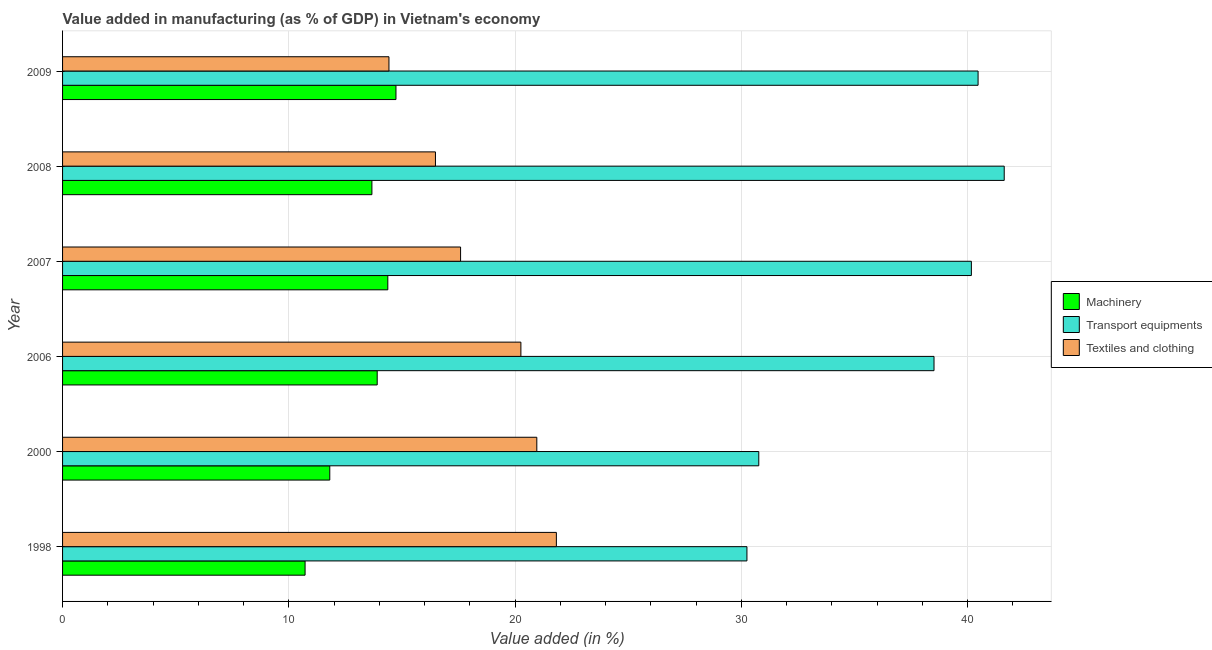How many bars are there on the 1st tick from the top?
Your answer should be very brief. 3. What is the label of the 5th group of bars from the top?
Give a very brief answer. 2000. In how many cases, is the number of bars for a given year not equal to the number of legend labels?
Make the answer very short. 0. What is the value added in manufacturing textile and clothing in 2007?
Your response must be concise. 17.59. Across all years, what is the maximum value added in manufacturing machinery?
Provide a succinct answer. 14.74. Across all years, what is the minimum value added in manufacturing transport equipments?
Keep it short and to the point. 30.25. In which year was the value added in manufacturing machinery minimum?
Make the answer very short. 1998. What is the total value added in manufacturing textile and clothing in the graph?
Your answer should be very brief. 111.55. What is the difference between the value added in manufacturing machinery in 2006 and that in 2009?
Give a very brief answer. -0.83. What is the difference between the value added in manufacturing transport equipments in 2007 and the value added in manufacturing textile and clothing in 1998?
Your response must be concise. 18.34. What is the average value added in manufacturing textile and clothing per year?
Offer a terse response. 18.59. In the year 2009, what is the difference between the value added in manufacturing textile and clothing and value added in manufacturing machinery?
Provide a short and direct response. -0.31. What is the ratio of the value added in manufacturing textile and clothing in 2007 to that in 2008?
Provide a short and direct response. 1.07. What is the difference between the highest and the second highest value added in manufacturing transport equipments?
Your answer should be very brief. 1.16. What is the difference between the highest and the lowest value added in manufacturing machinery?
Offer a terse response. 4.02. Is the sum of the value added in manufacturing transport equipments in 2006 and 2008 greater than the maximum value added in manufacturing machinery across all years?
Provide a succinct answer. Yes. What does the 1st bar from the top in 2009 represents?
Your answer should be very brief. Textiles and clothing. What does the 2nd bar from the bottom in 2008 represents?
Offer a very short reply. Transport equipments. Is it the case that in every year, the sum of the value added in manufacturing machinery and value added in manufacturing transport equipments is greater than the value added in manufacturing textile and clothing?
Provide a short and direct response. Yes. How many bars are there?
Give a very brief answer. 18. How many years are there in the graph?
Ensure brevity in your answer.  6. What is the difference between two consecutive major ticks on the X-axis?
Provide a succinct answer. 10. Are the values on the major ticks of X-axis written in scientific E-notation?
Give a very brief answer. No. Does the graph contain any zero values?
Keep it short and to the point. No. Does the graph contain grids?
Offer a terse response. Yes. How many legend labels are there?
Your response must be concise. 3. How are the legend labels stacked?
Keep it short and to the point. Vertical. What is the title of the graph?
Offer a very short reply. Value added in manufacturing (as % of GDP) in Vietnam's economy. What is the label or title of the X-axis?
Keep it short and to the point. Value added (in %). What is the Value added (in %) in Machinery in 1998?
Your response must be concise. 10.72. What is the Value added (in %) in Transport equipments in 1998?
Keep it short and to the point. 30.25. What is the Value added (in %) in Textiles and clothing in 1998?
Ensure brevity in your answer.  21.83. What is the Value added (in %) of Machinery in 2000?
Provide a succinct answer. 11.81. What is the Value added (in %) of Transport equipments in 2000?
Provide a succinct answer. 30.77. What is the Value added (in %) of Textiles and clothing in 2000?
Make the answer very short. 20.96. What is the Value added (in %) in Machinery in 2006?
Offer a terse response. 13.91. What is the Value added (in %) of Transport equipments in 2006?
Your response must be concise. 38.52. What is the Value added (in %) of Textiles and clothing in 2006?
Your response must be concise. 20.26. What is the Value added (in %) of Machinery in 2007?
Your response must be concise. 14.38. What is the Value added (in %) of Transport equipments in 2007?
Offer a very short reply. 40.17. What is the Value added (in %) of Textiles and clothing in 2007?
Offer a very short reply. 17.59. What is the Value added (in %) in Machinery in 2008?
Your answer should be compact. 13.67. What is the Value added (in %) in Transport equipments in 2008?
Offer a very short reply. 41.62. What is the Value added (in %) in Textiles and clothing in 2008?
Offer a terse response. 16.48. What is the Value added (in %) of Machinery in 2009?
Offer a very short reply. 14.74. What is the Value added (in %) of Transport equipments in 2009?
Keep it short and to the point. 40.47. What is the Value added (in %) in Textiles and clothing in 2009?
Offer a terse response. 14.43. Across all years, what is the maximum Value added (in %) of Machinery?
Your answer should be compact. 14.74. Across all years, what is the maximum Value added (in %) of Transport equipments?
Offer a terse response. 41.62. Across all years, what is the maximum Value added (in %) of Textiles and clothing?
Offer a terse response. 21.83. Across all years, what is the minimum Value added (in %) in Machinery?
Offer a very short reply. 10.72. Across all years, what is the minimum Value added (in %) of Transport equipments?
Give a very brief answer. 30.25. Across all years, what is the minimum Value added (in %) in Textiles and clothing?
Give a very brief answer. 14.43. What is the total Value added (in %) in Machinery in the graph?
Your answer should be very brief. 79.23. What is the total Value added (in %) of Transport equipments in the graph?
Offer a terse response. 221.81. What is the total Value added (in %) in Textiles and clothing in the graph?
Your answer should be compact. 111.55. What is the difference between the Value added (in %) of Machinery in 1998 and that in 2000?
Your response must be concise. -1.09. What is the difference between the Value added (in %) of Transport equipments in 1998 and that in 2000?
Your answer should be compact. -0.52. What is the difference between the Value added (in %) in Textiles and clothing in 1998 and that in 2000?
Your answer should be compact. 0.86. What is the difference between the Value added (in %) in Machinery in 1998 and that in 2006?
Your response must be concise. -3.19. What is the difference between the Value added (in %) of Transport equipments in 1998 and that in 2006?
Keep it short and to the point. -8.27. What is the difference between the Value added (in %) in Textiles and clothing in 1998 and that in 2006?
Your response must be concise. 1.57. What is the difference between the Value added (in %) of Machinery in 1998 and that in 2007?
Provide a succinct answer. -3.66. What is the difference between the Value added (in %) in Transport equipments in 1998 and that in 2007?
Make the answer very short. -9.92. What is the difference between the Value added (in %) of Textiles and clothing in 1998 and that in 2007?
Ensure brevity in your answer.  4.23. What is the difference between the Value added (in %) in Machinery in 1998 and that in 2008?
Provide a short and direct response. -2.95. What is the difference between the Value added (in %) in Transport equipments in 1998 and that in 2008?
Provide a short and direct response. -11.37. What is the difference between the Value added (in %) of Textiles and clothing in 1998 and that in 2008?
Ensure brevity in your answer.  5.34. What is the difference between the Value added (in %) in Machinery in 1998 and that in 2009?
Ensure brevity in your answer.  -4.02. What is the difference between the Value added (in %) of Transport equipments in 1998 and that in 2009?
Make the answer very short. -10.22. What is the difference between the Value added (in %) of Textiles and clothing in 1998 and that in 2009?
Your answer should be compact. 7.4. What is the difference between the Value added (in %) in Machinery in 2000 and that in 2006?
Provide a short and direct response. -2.1. What is the difference between the Value added (in %) in Transport equipments in 2000 and that in 2006?
Your answer should be very brief. -7.75. What is the difference between the Value added (in %) in Textiles and clothing in 2000 and that in 2006?
Make the answer very short. 0.7. What is the difference between the Value added (in %) of Machinery in 2000 and that in 2007?
Your answer should be very brief. -2.56. What is the difference between the Value added (in %) of Transport equipments in 2000 and that in 2007?
Offer a very short reply. -9.4. What is the difference between the Value added (in %) of Textiles and clothing in 2000 and that in 2007?
Offer a very short reply. 3.37. What is the difference between the Value added (in %) of Machinery in 2000 and that in 2008?
Provide a short and direct response. -1.86. What is the difference between the Value added (in %) in Transport equipments in 2000 and that in 2008?
Make the answer very short. -10.85. What is the difference between the Value added (in %) of Textiles and clothing in 2000 and that in 2008?
Your answer should be very brief. 4.48. What is the difference between the Value added (in %) in Machinery in 2000 and that in 2009?
Your answer should be very brief. -2.93. What is the difference between the Value added (in %) in Transport equipments in 2000 and that in 2009?
Give a very brief answer. -9.69. What is the difference between the Value added (in %) in Textiles and clothing in 2000 and that in 2009?
Offer a very short reply. 6.54. What is the difference between the Value added (in %) in Machinery in 2006 and that in 2007?
Provide a succinct answer. -0.47. What is the difference between the Value added (in %) of Transport equipments in 2006 and that in 2007?
Provide a short and direct response. -1.65. What is the difference between the Value added (in %) of Textiles and clothing in 2006 and that in 2007?
Provide a short and direct response. 2.67. What is the difference between the Value added (in %) in Machinery in 2006 and that in 2008?
Offer a very short reply. 0.23. What is the difference between the Value added (in %) in Transport equipments in 2006 and that in 2008?
Provide a succinct answer. -3.1. What is the difference between the Value added (in %) in Textiles and clothing in 2006 and that in 2008?
Keep it short and to the point. 3.78. What is the difference between the Value added (in %) of Machinery in 2006 and that in 2009?
Make the answer very short. -0.83. What is the difference between the Value added (in %) of Transport equipments in 2006 and that in 2009?
Keep it short and to the point. -1.95. What is the difference between the Value added (in %) in Textiles and clothing in 2006 and that in 2009?
Your response must be concise. 5.83. What is the difference between the Value added (in %) of Machinery in 2007 and that in 2008?
Your answer should be compact. 0.7. What is the difference between the Value added (in %) in Transport equipments in 2007 and that in 2008?
Offer a very short reply. -1.45. What is the difference between the Value added (in %) in Textiles and clothing in 2007 and that in 2008?
Keep it short and to the point. 1.11. What is the difference between the Value added (in %) of Machinery in 2007 and that in 2009?
Provide a succinct answer. -0.36. What is the difference between the Value added (in %) in Transport equipments in 2007 and that in 2009?
Your response must be concise. -0.3. What is the difference between the Value added (in %) of Textiles and clothing in 2007 and that in 2009?
Your answer should be compact. 3.17. What is the difference between the Value added (in %) of Machinery in 2008 and that in 2009?
Your answer should be compact. -1.06. What is the difference between the Value added (in %) in Transport equipments in 2008 and that in 2009?
Give a very brief answer. 1.16. What is the difference between the Value added (in %) in Textiles and clothing in 2008 and that in 2009?
Your response must be concise. 2.06. What is the difference between the Value added (in %) in Machinery in 1998 and the Value added (in %) in Transport equipments in 2000?
Ensure brevity in your answer.  -20.05. What is the difference between the Value added (in %) of Machinery in 1998 and the Value added (in %) of Textiles and clothing in 2000?
Provide a succinct answer. -10.24. What is the difference between the Value added (in %) in Transport equipments in 1998 and the Value added (in %) in Textiles and clothing in 2000?
Provide a short and direct response. 9.29. What is the difference between the Value added (in %) of Machinery in 1998 and the Value added (in %) of Transport equipments in 2006?
Your response must be concise. -27.8. What is the difference between the Value added (in %) of Machinery in 1998 and the Value added (in %) of Textiles and clothing in 2006?
Provide a succinct answer. -9.54. What is the difference between the Value added (in %) of Transport equipments in 1998 and the Value added (in %) of Textiles and clothing in 2006?
Give a very brief answer. 9.99. What is the difference between the Value added (in %) of Machinery in 1998 and the Value added (in %) of Transport equipments in 2007?
Offer a terse response. -29.45. What is the difference between the Value added (in %) of Machinery in 1998 and the Value added (in %) of Textiles and clothing in 2007?
Provide a succinct answer. -6.87. What is the difference between the Value added (in %) of Transport equipments in 1998 and the Value added (in %) of Textiles and clothing in 2007?
Provide a succinct answer. 12.66. What is the difference between the Value added (in %) in Machinery in 1998 and the Value added (in %) in Transport equipments in 2008?
Provide a short and direct response. -30.9. What is the difference between the Value added (in %) in Machinery in 1998 and the Value added (in %) in Textiles and clothing in 2008?
Offer a very short reply. -5.76. What is the difference between the Value added (in %) in Transport equipments in 1998 and the Value added (in %) in Textiles and clothing in 2008?
Provide a succinct answer. 13.77. What is the difference between the Value added (in %) in Machinery in 1998 and the Value added (in %) in Transport equipments in 2009?
Offer a terse response. -29.75. What is the difference between the Value added (in %) in Machinery in 1998 and the Value added (in %) in Textiles and clothing in 2009?
Keep it short and to the point. -3.71. What is the difference between the Value added (in %) in Transport equipments in 1998 and the Value added (in %) in Textiles and clothing in 2009?
Offer a terse response. 15.82. What is the difference between the Value added (in %) of Machinery in 2000 and the Value added (in %) of Transport equipments in 2006?
Provide a short and direct response. -26.71. What is the difference between the Value added (in %) in Machinery in 2000 and the Value added (in %) in Textiles and clothing in 2006?
Keep it short and to the point. -8.45. What is the difference between the Value added (in %) of Transport equipments in 2000 and the Value added (in %) of Textiles and clothing in 2006?
Keep it short and to the point. 10.52. What is the difference between the Value added (in %) in Machinery in 2000 and the Value added (in %) in Transport equipments in 2007?
Offer a very short reply. -28.36. What is the difference between the Value added (in %) of Machinery in 2000 and the Value added (in %) of Textiles and clothing in 2007?
Give a very brief answer. -5.78. What is the difference between the Value added (in %) in Transport equipments in 2000 and the Value added (in %) in Textiles and clothing in 2007?
Your answer should be compact. 13.18. What is the difference between the Value added (in %) of Machinery in 2000 and the Value added (in %) of Transport equipments in 2008?
Offer a very short reply. -29.81. What is the difference between the Value added (in %) of Machinery in 2000 and the Value added (in %) of Textiles and clothing in 2008?
Offer a very short reply. -4.67. What is the difference between the Value added (in %) of Transport equipments in 2000 and the Value added (in %) of Textiles and clothing in 2008?
Your answer should be compact. 14.29. What is the difference between the Value added (in %) of Machinery in 2000 and the Value added (in %) of Transport equipments in 2009?
Provide a succinct answer. -28.66. What is the difference between the Value added (in %) in Machinery in 2000 and the Value added (in %) in Textiles and clothing in 2009?
Ensure brevity in your answer.  -2.62. What is the difference between the Value added (in %) in Transport equipments in 2000 and the Value added (in %) in Textiles and clothing in 2009?
Keep it short and to the point. 16.35. What is the difference between the Value added (in %) in Machinery in 2006 and the Value added (in %) in Transport equipments in 2007?
Your answer should be compact. -26.26. What is the difference between the Value added (in %) of Machinery in 2006 and the Value added (in %) of Textiles and clothing in 2007?
Offer a very short reply. -3.69. What is the difference between the Value added (in %) of Transport equipments in 2006 and the Value added (in %) of Textiles and clothing in 2007?
Provide a succinct answer. 20.93. What is the difference between the Value added (in %) of Machinery in 2006 and the Value added (in %) of Transport equipments in 2008?
Your response must be concise. -27.72. What is the difference between the Value added (in %) in Machinery in 2006 and the Value added (in %) in Textiles and clothing in 2008?
Provide a short and direct response. -2.57. What is the difference between the Value added (in %) of Transport equipments in 2006 and the Value added (in %) of Textiles and clothing in 2008?
Your answer should be compact. 22.04. What is the difference between the Value added (in %) of Machinery in 2006 and the Value added (in %) of Transport equipments in 2009?
Ensure brevity in your answer.  -26.56. What is the difference between the Value added (in %) in Machinery in 2006 and the Value added (in %) in Textiles and clothing in 2009?
Offer a terse response. -0.52. What is the difference between the Value added (in %) in Transport equipments in 2006 and the Value added (in %) in Textiles and clothing in 2009?
Provide a short and direct response. 24.09. What is the difference between the Value added (in %) in Machinery in 2007 and the Value added (in %) in Transport equipments in 2008?
Your response must be concise. -27.25. What is the difference between the Value added (in %) in Machinery in 2007 and the Value added (in %) in Textiles and clothing in 2008?
Give a very brief answer. -2.11. What is the difference between the Value added (in %) of Transport equipments in 2007 and the Value added (in %) of Textiles and clothing in 2008?
Keep it short and to the point. 23.69. What is the difference between the Value added (in %) of Machinery in 2007 and the Value added (in %) of Transport equipments in 2009?
Provide a short and direct response. -26.09. What is the difference between the Value added (in %) of Machinery in 2007 and the Value added (in %) of Textiles and clothing in 2009?
Your answer should be compact. -0.05. What is the difference between the Value added (in %) of Transport equipments in 2007 and the Value added (in %) of Textiles and clothing in 2009?
Ensure brevity in your answer.  25.74. What is the difference between the Value added (in %) of Machinery in 2008 and the Value added (in %) of Transport equipments in 2009?
Your answer should be compact. -26.79. What is the difference between the Value added (in %) of Machinery in 2008 and the Value added (in %) of Textiles and clothing in 2009?
Your answer should be compact. -0.75. What is the difference between the Value added (in %) in Transport equipments in 2008 and the Value added (in %) in Textiles and clothing in 2009?
Keep it short and to the point. 27.2. What is the average Value added (in %) in Machinery per year?
Offer a terse response. 13.2. What is the average Value added (in %) of Transport equipments per year?
Provide a short and direct response. 36.97. What is the average Value added (in %) in Textiles and clothing per year?
Ensure brevity in your answer.  18.59. In the year 1998, what is the difference between the Value added (in %) of Machinery and Value added (in %) of Transport equipments?
Your response must be concise. -19.53. In the year 1998, what is the difference between the Value added (in %) of Machinery and Value added (in %) of Textiles and clothing?
Your response must be concise. -11.11. In the year 1998, what is the difference between the Value added (in %) in Transport equipments and Value added (in %) in Textiles and clothing?
Keep it short and to the point. 8.42. In the year 2000, what is the difference between the Value added (in %) of Machinery and Value added (in %) of Transport equipments?
Your answer should be compact. -18.96. In the year 2000, what is the difference between the Value added (in %) of Machinery and Value added (in %) of Textiles and clothing?
Offer a terse response. -9.15. In the year 2000, what is the difference between the Value added (in %) of Transport equipments and Value added (in %) of Textiles and clothing?
Provide a short and direct response. 9.81. In the year 2006, what is the difference between the Value added (in %) in Machinery and Value added (in %) in Transport equipments?
Give a very brief answer. -24.61. In the year 2006, what is the difference between the Value added (in %) in Machinery and Value added (in %) in Textiles and clothing?
Offer a terse response. -6.35. In the year 2006, what is the difference between the Value added (in %) of Transport equipments and Value added (in %) of Textiles and clothing?
Offer a very short reply. 18.26. In the year 2007, what is the difference between the Value added (in %) of Machinery and Value added (in %) of Transport equipments?
Give a very brief answer. -25.79. In the year 2007, what is the difference between the Value added (in %) in Machinery and Value added (in %) in Textiles and clothing?
Provide a succinct answer. -3.22. In the year 2007, what is the difference between the Value added (in %) in Transport equipments and Value added (in %) in Textiles and clothing?
Offer a very short reply. 22.58. In the year 2008, what is the difference between the Value added (in %) in Machinery and Value added (in %) in Transport equipments?
Give a very brief answer. -27.95. In the year 2008, what is the difference between the Value added (in %) in Machinery and Value added (in %) in Textiles and clothing?
Provide a succinct answer. -2.81. In the year 2008, what is the difference between the Value added (in %) of Transport equipments and Value added (in %) of Textiles and clothing?
Your response must be concise. 25.14. In the year 2009, what is the difference between the Value added (in %) of Machinery and Value added (in %) of Transport equipments?
Your answer should be compact. -25.73. In the year 2009, what is the difference between the Value added (in %) in Machinery and Value added (in %) in Textiles and clothing?
Your response must be concise. 0.31. In the year 2009, what is the difference between the Value added (in %) in Transport equipments and Value added (in %) in Textiles and clothing?
Your answer should be very brief. 26.04. What is the ratio of the Value added (in %) in Machinery in 1998 to that in 2000?
Offer a very short reply. 0.91. What is the ratio of the Value added (in %) of Transport equipments in 1998 to that in 2000?
Provide a short and direct response. 0.98. What is the ratio of the Value added (in %) of Textiles and clothing in 1998 to that in 2000?
Make the answer very short. 1.04. What is the ratio of the Value added (in %) in Machinery in 1998 to that in 2006?
Offer a terse response. 0.77. What is the ratio of the Value added (in %) in Transport equipments in 1998 to that in 2006?
Your response must be concise. 0.79. What is the ratio of the Value added (in %) of Textiles and clothing in 1998 to that in 2006?
Your response must be concise. 1.08. What is the ratio of the Value added (in %) of Machinery in 1998 to that in 2007?
Your answer should be very brief. 0.75. What is the ratio of the Value added (in %) of Transport equipments in 1998 to that in 2007?
Offer a terse response. 0.75. What is the ratio of the Value added (in %) in Textiles and clothing in 1998 to that in 2007?
Keep it short and to the point. 1.24. What is the ratio of the Value added (in %) in Machinery in 1998 to that in 2008?
Your answer should be compact. 0.78. What is the ratio of the Value added (in %) in Transport equipments in 1998 to that in 2008?
Your answer should be compact. 0.73. What is the ratio of the Value added (in %) in Textiles and clothing in 1998 to that in 2008?
Keep it short and to the point. 1.32. What is the ratio of the Value added (in %) in Machinery in 1998 to that in 2009?
Ensure brevity in your answer.  0.73. What is the ratio of the Value added (in %) in Transport equipments in 1998 to that in 2009?
Your answer should be very brief. 0.75. What is the ratio of the Value added (in %) of Textiles and clothing in 1998 to that in 2009?
Your response must be concise. 1.51. What is the ratio of the Value added (in %) in Machinery in 2000 to that in 2006?
Your answer should be compact. 0.85. What is the ratio of the Value added (in %) in Transport equipments in 2000 to that in 2006?
Your response must be concise. 0.8. What is the ratio of the Value added (in %) of Textiles and clothing in 2000 to that in 2006?
Your answer should be very brief. 1.03. What is the ratio of the Value added (in %) in Machinery in 2000 to that in 2007?
Provide a short and direct response. 0.82. What is the ratio of the Value added (in %) of Transport equipments in 2000 to that in 2007?
Provide a succinct answer. 0.77. What is the ratio of the Value added (in %) in Textiles and clothing in 2000 to that in 2007?
Your answer should be very brief. 1.19. What is the ratio of the Value added (in %) in Machinery in 2000 to that in 2008?
Keep it short and to the point. 0.86. What is the ratio of the Value added (in %) in Transport equipments in 2000 to that in 2008?
Give a very brief answer. 0.74. What is the ratio of the Value added (in %) in Textiles and clothing in 2000 to that in 2008?
Make the answer very short. 1.27. What is the ratio of the Value added (in %) in Machinery in 2000 to that in 2009?
Offer a terse response. 0.8. What is the ratio of the Value added (in %) of Transport equipments in 2000 to that in 2009?
Offer a terse response. 0.76. What is the ratio of the Value added (in %) of Textiles and clothing in 2000 to that in 2009?
Offer a terse response. 1.45. What is the ratio of the Value added (in %) in Machinery in 2006 to that in 2007?
Keep it short and to the point. 0.97. What is the ratio of the Value added (in %) in Transport equipments in 2006 to that in 2007?
Give a very brief answer. 0.96. What is the ratio of the Value added (in %) of Textiles and clothing in 2006 to that in 2007?
Keep it short and to the point. 1.15. What is the ratio of the Value added (in %) in Machinery in 2006 to that in 2008?
Offer a very short reply. 1.02. What is the ratio of the Value added (in %) of Transport equipments in 2006 to that in 2008?
Your response must be concise. 0.93. What is the ratio of the Value added (in %) of Textiles and clothing in 2006 to that in 2008?
Offer a very short reply. 1.23. What is the ratio of the Value added (in %) in Machinery in 2006 to that in 2009?
Make the answer very short. 0.94. What is the ratio of the Value added (in %) of Transport equipments in 2006 to that in 2009?
Your answer should be compact. 0.95. What is the ratio of the Value added (in %) of Textiles and clothing in 2006 to that in 2009?
Keep it short and to the point. 1.4. What is the ratio of the Value added (in %) of Machinery in 2007 to that in 2008?
Your answer should be very brief. 1.05. What is the ratio of the Value added (in %) of Transport equipments in 2007 to that in 2008?
Make the answer very short. 0.97. What is the ratio of the Value added (in %) of Textiles and clothing in 2007 to that in 2008?
Ensure brevity in your answer.  1.07. What is the ratio of the Value added (in %) in Machinery in 2007 to that in 2009?
Your answer should be compact. 0.98. What is the ratio of the Value added (in %) in Transport equipments in 2007 to that in 2009?
Offer a very short reply. 0.99. What is the ratio of the Value added (in %) in Textiles and clothing in 2007 to that in 2009?
Provide a succinct answer. 1.22. What is the ratio of the Value added (in %) of Machinery in 2008 to that in 2009?
Offer a terse response. 0.93. What is the ratio of the Value added (in %) in Transport equipments in 2008 to that in 2009?
Offer a very short reply. 1.03. What is the ratio of the Value added (in %) in Textiles and clothing in 2008 to that in 2009?
Provide a short and direct response. 1.14. What is the difference between the highest and the second highest Value added (in %) in Machinery?
Keep it short and to the point. 0.36. What is the difference between the highest and the second highest Value added (in %) of Transport equipments?
Keep it short and to the point. 1.16. What is the difference between the highest and the second highest Value added (in %) in Textiles and clothing?
Your answer should be compact. 0.86. What is the difference between the highest and the lowest Value added (in %) in Machinery?
Keep it short and to the point. 4.02. What is the difference between the highest and the lowest Value added (in %) in Transport equipments?
Offer a terse response. 11.37. What is the difference between the highest and the lowest Value added (in %) of Textiles and clothing?
Offer a very short reply. 7.4. 